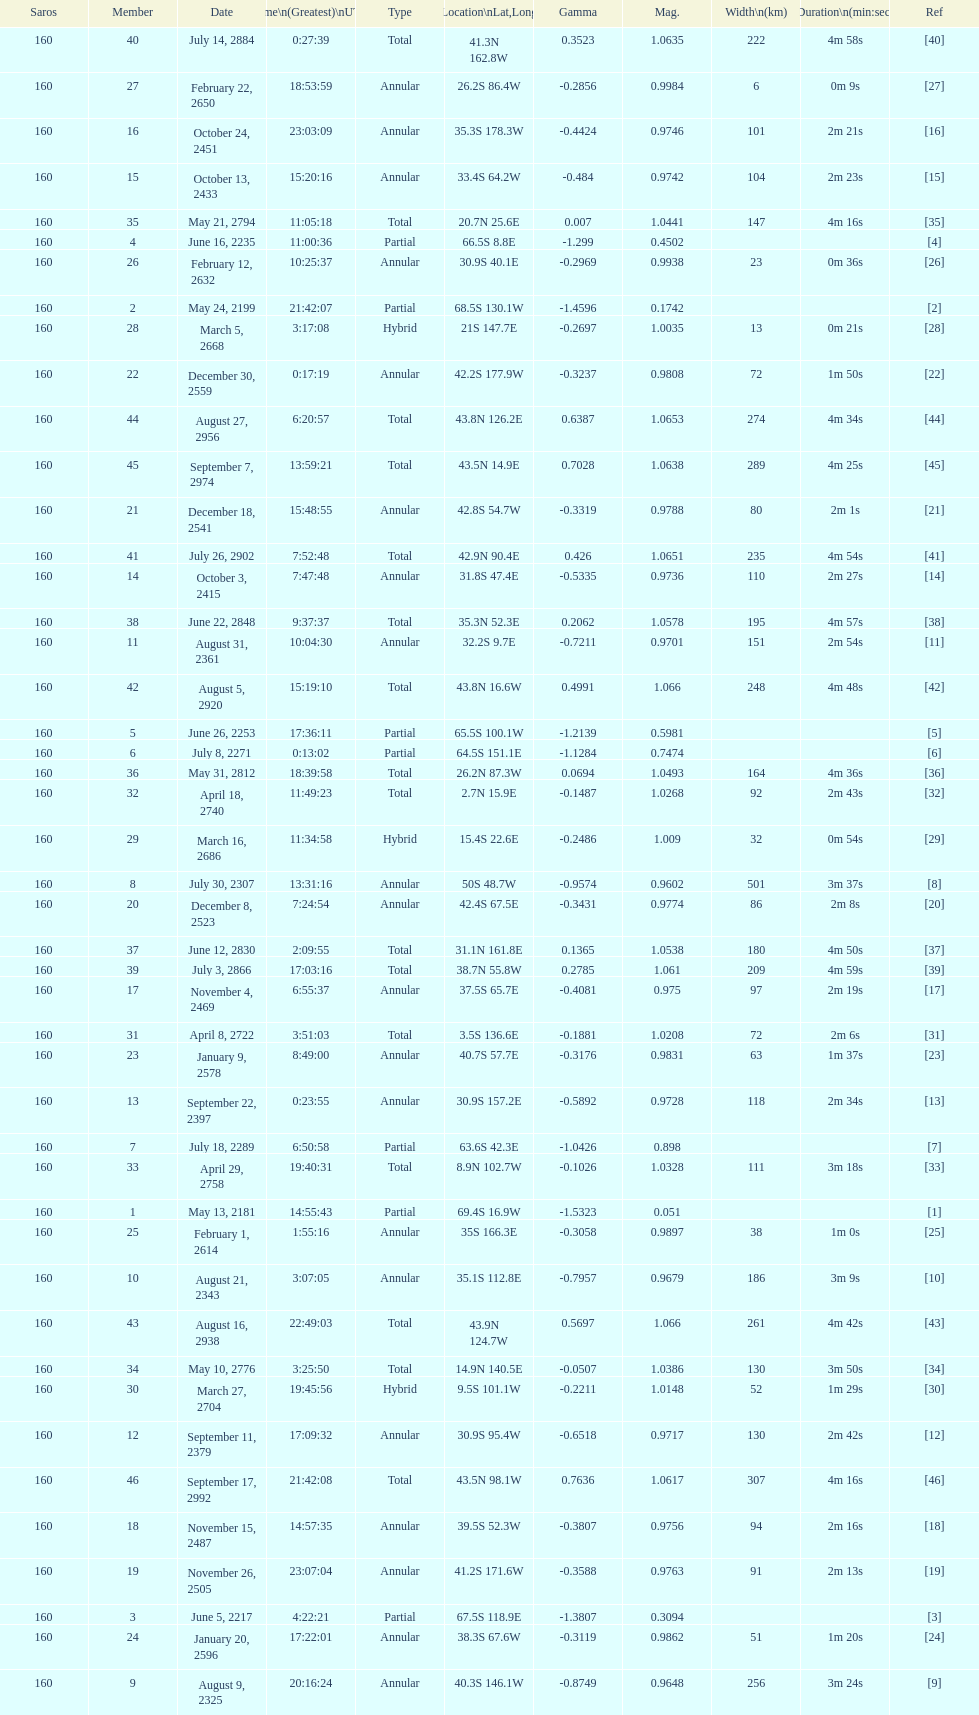When did the first solar saros with a magnitude of greater than 1.00 occur? March 5, 2668. 